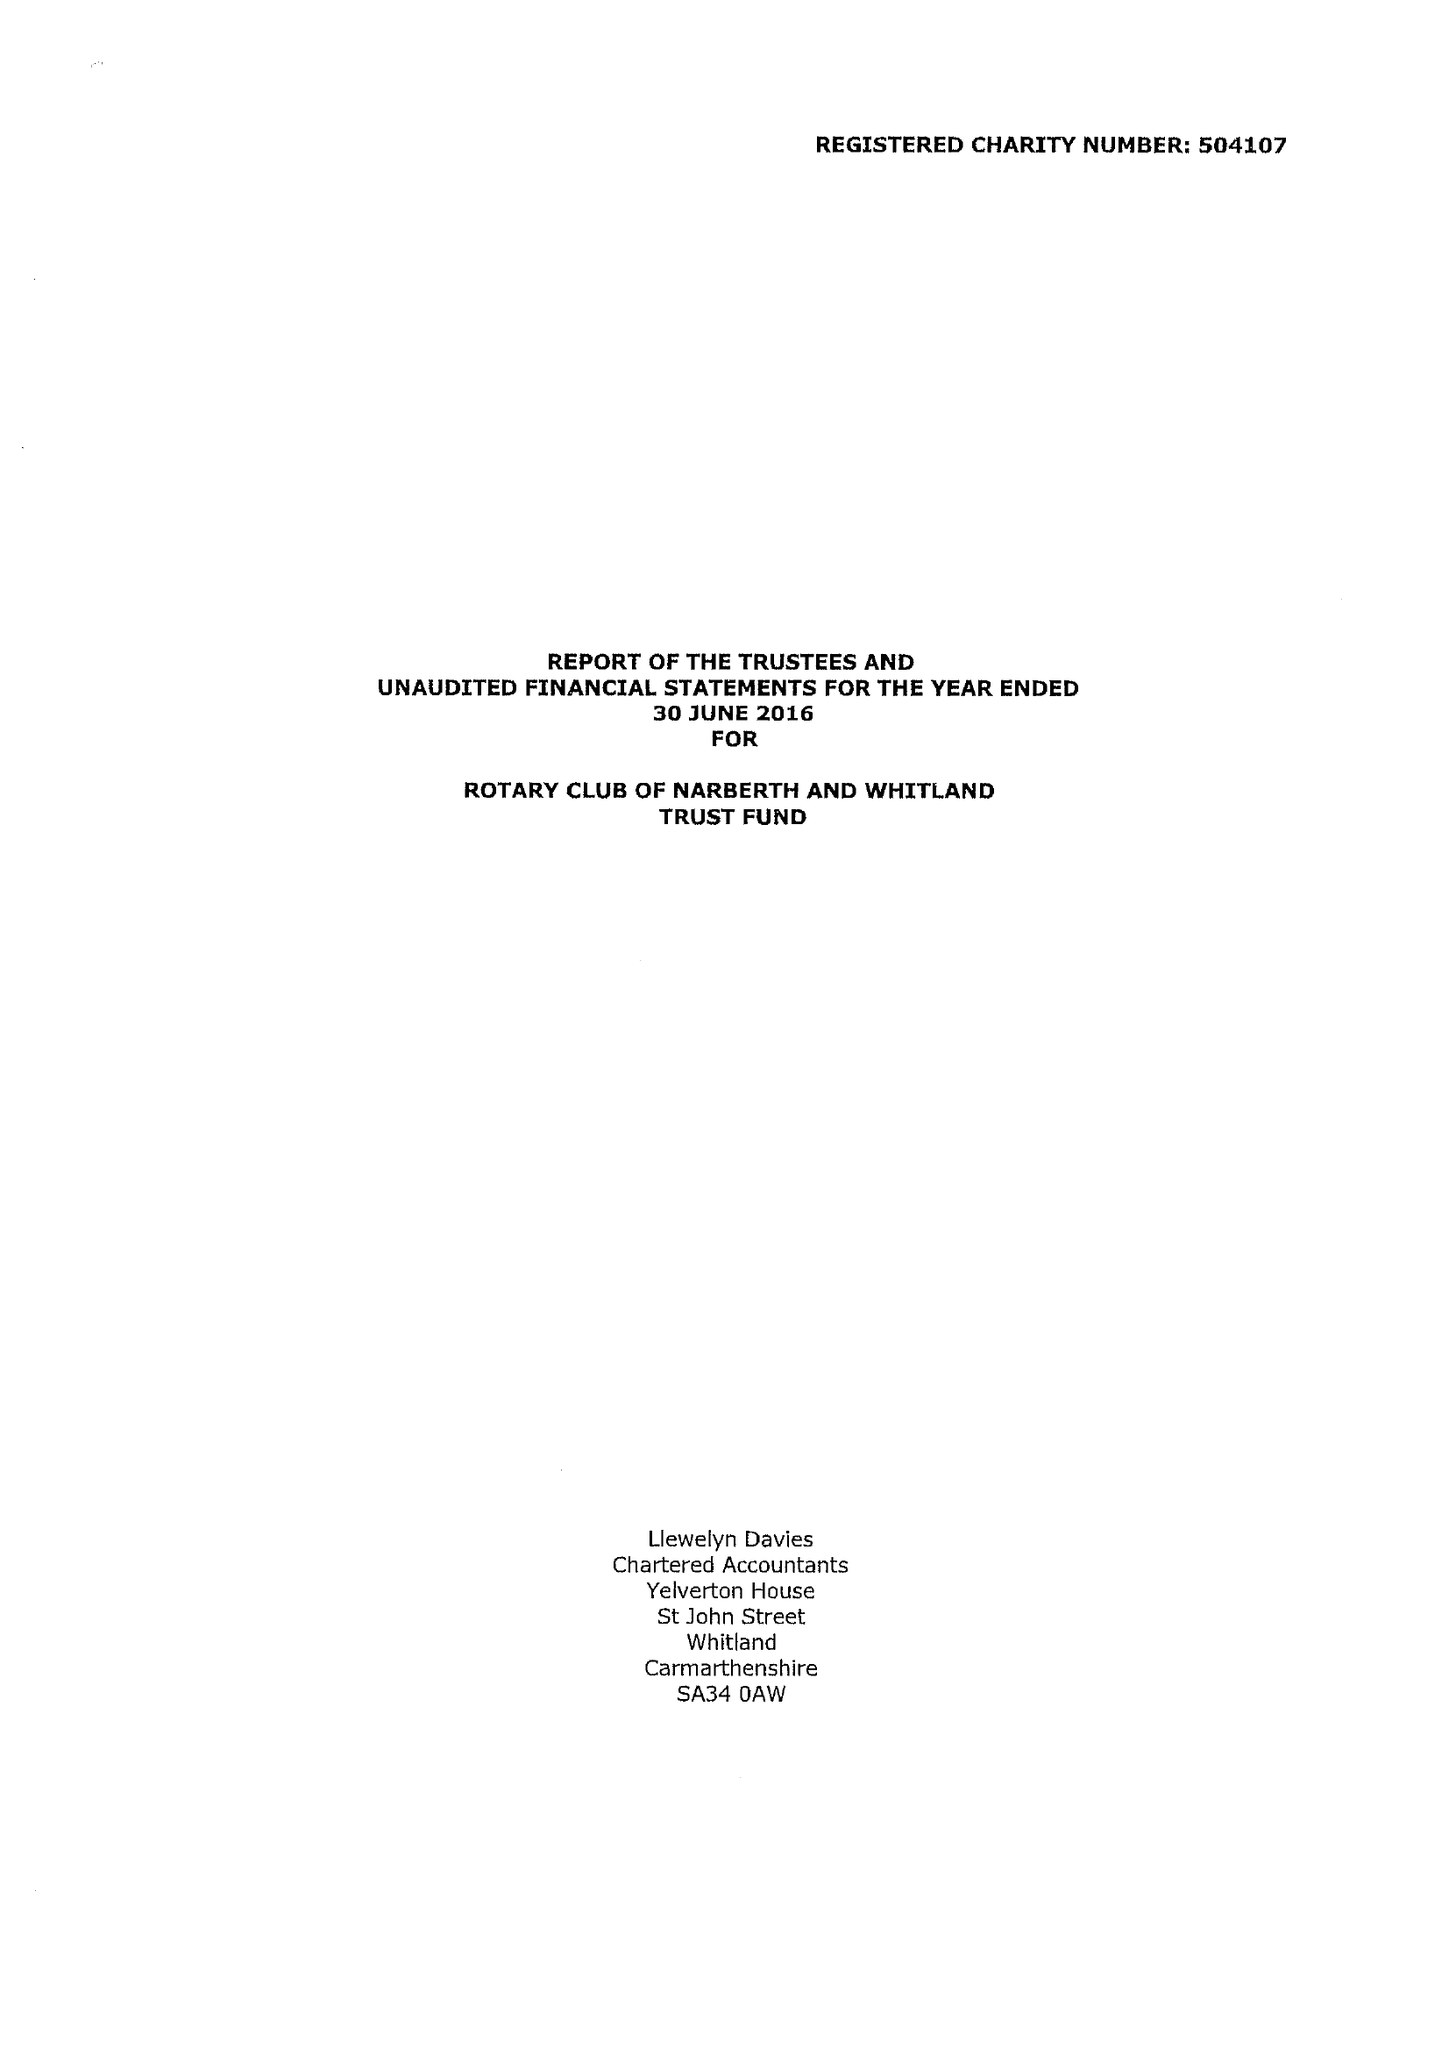What is the value for the report_date?
Answer the question using a single word or phrase. 2016-06-30 